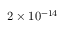<formula> <loc_0><loc_0><loc_500><loc_500>2 \times 1 0 ^ { - 1 4 }</formula> 